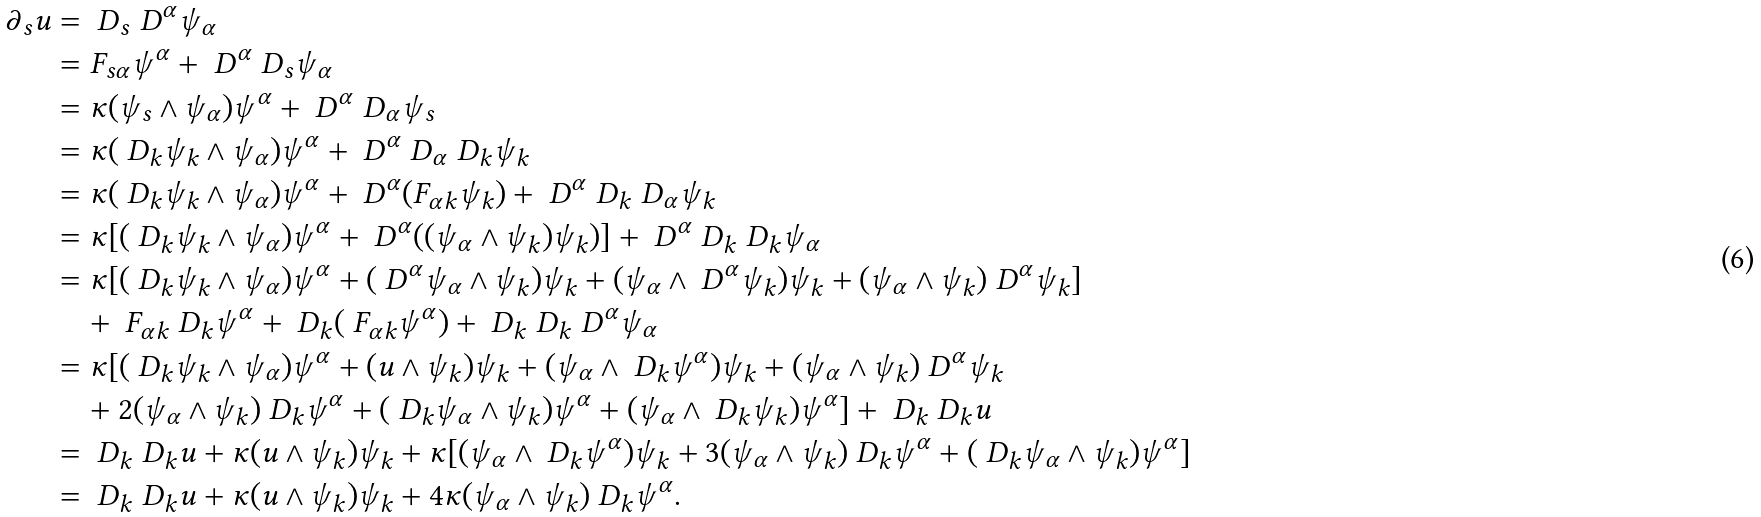Convert formula to latex. <formula><loc_0><loc_0><loc_500><loc_500>\partial _ { s } u & = \ D _ { s } \ D ^ { \alpha } \psi _ { \alpha } \\ & = F _ { s \alpha } \psi ^ { \alpha } + \ D ^ { \alpha } \ D _ { s } \psi _ { \alpha } \\ & = \kappa ( \psi _ { s } \wedge \psi _ { \alpha } ) \psi ^ { \alpha } + \ D ^ { \alpha } \ D _ { \alpha } \psi _ { s } \\ & = \kappa ( \ D _ { k } \psi _ { k } \wedge \psi _ { \alpha } ) \psi ^ { \alpha } + \ D ^ { \alpha } \ D _ { \alpha } \ D _ { k } \psi _ { k } \\ & = \kappa ( \ D _ { k } \psi _ { k } \wedge \psi _ { \alpha } ) \psi ^ { \alpha } + \ D ^ { \alpha } ( F _ { \alpha k } \psi _ { k } ) + \ D ^ { \alpha } \ D _ { k } \ D _ { \alpha } \psi _ { k } \\ & = \kappa [ ( \ D _ { k } \psi _ { k } \wedge \psi _ { \alpha } ) \psi ^ { \alpha } + \ D ^ { \alpha } ( ( \psi _ { \alpha } \wedge \psi _ { k } ) \psi _ { k } ) ] + \ D ^ { \alpha } \ D _ { k } \ D _ { k } \psi _ { \alpha } \\ & = \kappa [ ( \ D _ { k } \psi _ { k } \wedge \psi _ { \alpha } ) \psi ^ { \alpha } + ( \ D ^ { \alpha } \psi _ { \alpha } \wedge \psi _ { k } ) \psi _ { k } + ( \psi _ { \alpha } \wedge \ D ^ { \alpha } \psi _ { k } ) \psi _ { k } + ( \psi _ { \alpha } \wedge \psi _ { k } ) \ D ^ { \alpha } \psi _ { k } ] \\ & \quad + \ F _ { \alpha k } \ D _ { k } \psi ^ { \alpha } + \ D _ { k } ( \ F _ { \alpha k } \psi ^ { \alpha } ) + \ D _ { k } \ D _ { k } \ D ^ { \alpha } \psi _ { \alpha } \\ & = \kappa [ ( \ D _ { k } \psi _ { k } \wedge \psi _ { \alpha } ) \psi ^ { \alpha } + ( u \wedge \psi _ { k } ) \psi _ { k } + ( \psi _ { \alpha } \wedge \ D _ { k } \psi ^ { \alpha } ) \psi _ { k } + ( \psi _ { \alpha } \wedge \psi _ { k } ) \ D ^ { \alpha } \psi _ { k } \\ & \quad + 2 ( \psi _ { \alpha } \wedge \psi _ { k } ) \ D _ { k } \psi ^ { \alpha } + ( \ D _ { k } \psi _ { \alpha } \wedge \psi _ { k } ) \psi ^ { \alpha } + ( \psi _ { \alpha } \wedge \ D _ { k } \psi _ { k } ) \psi ^ { \alpha } ] + \ D _ { k } \ D _ { k } u \\ & = \ D _ { k } \ D _ { k } u + \kappa ( u \wedge \psi _ { k } ) \psi _ { k } + \kappa [ ( \psi _ { \alpha } \wedge \ D _ { k } \psi ^ { \alpha } ) \psi _ { k } + 3 ( \psi _ { \alpha } \wedge \psi _ { k } ) \ D _ { k } \psi ^ { \alpha } + ( \ D _ { k } \psi _ { \alpha } \wedge \psi _ { k } ) \psi ^ { \alpha } ] \\ & = \ D _ { k } \ D _ { k } u + \kappa ( u \wedge \psi _ { k } ) \psi _ { k } + 4 \kappa ( \psi _ { \alpha } \wedge \psi _ { k } ) \ D _ { k } \psi ^ { \alpha } .</formula> 